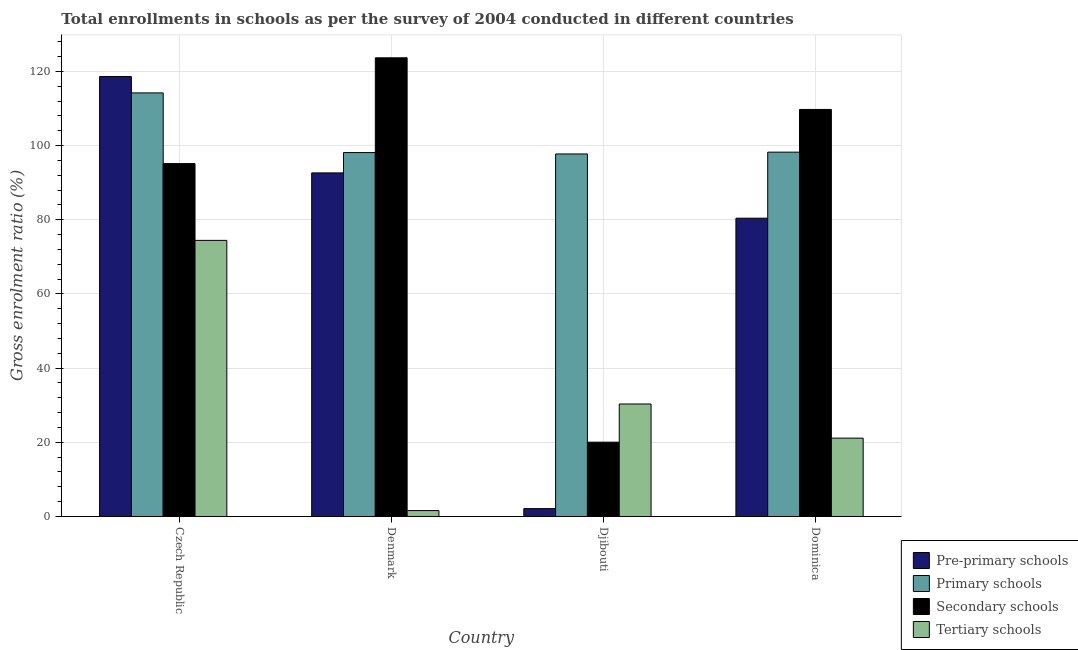How many groups of bars are there?
Your response must be concise. 4. Are the number of bars on each tick of the X-axis equal?
Keep it short and to the point. Yes. How many bars are there on the 1st tick from the left?
Give a very brief answer. 4. What is the label of the 3rd group of bars from the left?
Keep it short and to the point. Djibouti. What is the gross enrolment ratio in pre-primary schools in Dominica?
Your response must be concise. 80.43. Across all countries, what is the maximum gross enrolment ratio in tertiary schools?
Your answer should be compact. 74.44. Across all countries, what is the minimum gross enrolment ratio in primary schools?
Give a very brief answer. 97.75. In which country was the gross enrolment ratio in primary schools maximum?
Provide a short and direct response. Czech Republic. In which country was the gross enrolment ratio in pre-primary schools minimum?
Make the answer very short. Djibouti. What is the total gross enrolment ratio in primary schools in the graph?
Make the answer very short. 408.3. What is the difference between the gross enrolment ratio in tertiary schools in Denmark and that in Djibouti?
Provide a short and direct response. -28.74. What is the difference between the gross enrolment ratio in pre-primary schools in Denmark and the gross enrolment ratio in secondary schools in Czech Republic?
Keep it short and to the point. -2.51. What is the average gross enrolment ratio in pre-primary schools per country?
Your answer should be very brief. 73.45. What is the difference between the gross enrolment ratio in primary schools and gross enrolment ratio in tertiary schools in Dominica?
Provide a succinct answer. 77.1. What is the ratio of the gross enrolment ratio in pre-primary schools in Djibouti to that in Dominica?
Give a very brief answer. 0.03. Is the gross enrolment ratio in pre-primary schools in Czech Republic less than that in Denmark?
Provide a short and direct response. No. Is the difference between the gross enrolment ratio in secondary schools in Czech Republic and Dominica greater than the difference between the gross enrolment ratio in pre-primary schools in Czech Republic and Dominica?
Your answer should be very brief. No. What is the difference between the highest and the second highest gross enrolment ratio in pre-primary schools?
Give a very brief answer. 25.98. What is the difference between the highest and the lowest gross enrolment ratio in secondary schools?
Make the answer very short. 103.63. In how many countries, is the gross enrolment ratio in primary schools greater than the average gross enrolment ratio in primary schools taken over all countries?
Provide a succinct answer. 1. What does the 2nd bar from the left in Denmark represents?
Ensure brevity in your answer.  Primary schools. What does the 3rd bar from the right in Denmark represents?
Make the answer very short. Primary schools. Is it the case that in every country, the sum of the gross enrolment ratio in pre-primary schools and gross enrolment ratio in primary schools is greater than the gross enrolment ratio in secondary schools?
Give a very brief answer. Yes. How many countries are there in the graph?
Give a very brief answer. 4. What is the difference between two consecutive major ticks on the Y-axis?
Ensure brevity in your answer.  20. Are the values on the major ticks of Y-axis written in scientific E-notation?
Ensure brevity in your answer.  No. Does the graph contain grids?
Offer a very short reply. Yes. Where does the legend appear in the graph?
Your response must be concise. Bottom right. How are the legend labels stacked?
Your answer should be very brief. Vertical. What is the title of the graph?
Your answer should be compact. Total enrollments in schools as per the survey of 2004 conducted in different countries. What is the label or title of the Y-axis?
Your answer should be very brief. Gross enrolment ratio (%). What is the Gross enrolment ratio (%) in Pre-primary schools in Czech Republic?
Give a very brief answer. 118.62. What is the Gross enrolment ratio (%) of Primary schools in Czech Republic?
Offer a terse response. 114.2. What is the Gross enrolment ratio (%) of Secondary schools in Czech Republic?
Provide a short and direct response. 95.15. What is the Gross enrolment ratio (%) in Tertiary schools in Czech Republic?
Give a very brief answer. 74.44. What is the Gross enrolment ratio (%) in Pre-primary schools in Denmark?
Offer a very short reply. 92.64. What is the Gross enrolment ratio (%) in Primary schools in Denmark?
Give a very brief answer. 98.12. What is the Gross enrolment ratio (%) of Secondary schools in Denmark?
Give a very brief answer. 123.67. What is the Gross enrolment ratio (%) of Tertiary schools in Denmark?
Your answer should be very brief. 1.59. What is the Gross enrolment ratio (%) of Pre-primary schools in Djibouti?
Provide a succinct answer. 2.12. What is the Gross enrolment ratio (%) of Primary schools in Djibouti?
Provide a short and direct response. 97.75. What is the Gross enrolment ratio (%) of Secondary schools in Djibouti?
Offer a very short reply. 20.04. What is the Gross enrolment ratio (%) of Tertiary schools in Djibouti?
Make the answer very short. 30.33. What is the Gross enrolment ratio (%) of Pre-primary schools in Dominica?
Ensure brevity in your answer.  80.43. What is the Gross enrolment ratio (%) in Primary schools in Dominica?
Your response must be concise. 98.23. What is the Gross enrolment ratio (%) in Secondary schools in Dominica?
Give a very brief answer. 109.75. What is the Gross enrolment ratio (%) in Tertiary schools in Dominica?
Your answer should be compact. 21.13. Across all countries, what is the maximum Gross enrolment ratio (%) of Pre-primary schools?
Your response must be concise. 118.62. Across all countries, what is the maximum Gross enrolment ratio (%) of Primary schools?
Ensure brevity in your answer.  114.2. Across all countries, what is the maximum Gross enrolment ratio (%) in Secondary schools?
Your answer should be compact. 123.67. Across all countries, what is the maximum Gross enrolment ratio (%) of Tertiary schools?
Ensure brevity in your answer.  74.44. Across all countries, what is the minimum Gross enrolment ratio (%) in Pre-primary schools?
Ensure brevity in your answer.  2.12. Across all countries, what is the minimum Gross enrolment ratio (%) of Primary schools?
Your answer should be very brief. 97.75. Across all countries, what is the minimum Gross enrolment ratio (%) in Secondary schools?
Keep it short and to the point. 20.04. Across all countries, what is the minimum Gross enrolment ratio (%) of Tertiary schools?
Make the answer very short. 1.59. What is the total Gross enrolment ratio (%) in Pre-primary schools in the graph?
Ensure brevity in your answer.  293.8. What is the total Gross enrolment ratio (%) in Primary schools in the graph?
Provide a short and direct response. 408.3. What is the total Gross enrolment ratio (%) of Secondary schools in the graph?
Your answer should be very brief. 348.6. What is the total Gross enrolment ratio (%) of Tertiary schools in the graph?
Your answer should be compact. 127.49. What is the difference between the Gross enrolment ratio (%) of Pre-primary schools in Czech Republic and that in Denmark?
Give a very brief answer. 25.98. What is the difference between the Gross enrolment ratio (%) of Primary schools in Czech Republic and that in Denmark?
Make the answer very short. 16.09. What is the difference between the Gross enrolment ratio (%) in Secondary schools in Czech Republic and that in Denmark?
Offer a terse response. -28.52. What is the difference between the Gross enrolment ratio (%) in Tertiary schools in Czech Republic and that in Denmark?
Provide a short and direct response. 72.85. What is the difference between the Gross enrolment ratio (%) in Pre-primary schools in Czech Republic and that in Djibouti?
Keep it short and to the point. 116.49. What is the difference between the Gross enrolment ratio (%) of Primary schools in Czech Republic and that in Djibouti?
Offer a terse response. 16.46. What is the difference between the Gross enrolment ratio (%) of Secondary schools in Czech Republic and that in Djibouti?
Make the answer very short. 75.11. What is the difference between the Gross enrolment ratio (%) in Tertiary schools in Czech Republic and that in Djibouti?
Ensure brevity in your answer.  44.11. What is the difference between the Gross enrolment ratio (%) in Pre-primary schools in Czech Republic and that in Dominica?
Your response must be concise. 38.19. What is the difference between the Gross enrolment ratio (%) in Primary schools in Czech Republic and that in Dominica?
Keep it short and to the point. 15.97. What is the difference between the Gross enrolment ratio (%) in Secondary schools in Czech Republic and that in Dominica?
Offer a very short reply. -14.6. What is the difference between the Gross enrolment ratio (%) of Tertiary schools in Czech Republic and that in Dominica?
Your response must be concise. 53.32. What is the difference between the Gross enrolment ratio (%) of Pre-primary schools in Denmark and that in Djibouti?
Offer a terse response. 90.51. What is the difference between the Gross enrolment ratio (%) in Primary schools in Denmark and that in Djibouti?
Provide a short and direct response. 0.37. What is the difference between the Gross enrolment ratio (%) of Secondary schools in Denmark and that in Djibouti?
Offer a very short reply. 103.63. What is the difference between the Gross enrolment ratio (%) in Tertiary schools in Denmark and that in Djibouti?
Keep it short and to the point. -28.74. What is the difference between the Gross enrolment ratio (%) of Pre-primary schools in Denmark and that in Dominica?
Provide a short and direct response. 12.21. What is the difference between the Gross enrolment ratio (%) of Primary schools in Denmark and that in Dominica?
Your answer should be compact. -0.11. What is the difference between the Gross enrolment ratio (%) of Secondary schools in Denmark and that in Dominica?
Offer a very short reply. 13.92. What is the difference between the Gross enrolment ratio (%) in Tertiary schools in Denmark and that in Dominica?
Ensure brevity in your answer.  -19.54. What is the difference between the Gross enrolment ratio (%) of Pre-primary schools in Djibouti and that in Dominica?
Your response must be concise. -78.3. What is the difference between the Gross enrolment ratio (%) in Primary schools in Djibouti and that in Dominica?
Keep it short and to the point. -0.49. What is the difference between the Gross enrolment ratio (%) in Secondary schools in Djibouti and that in Dominica?
Your answer should be compact. -89.71. What is the difference between the Gross enrolment ratio (%) in Tertiary schools in Djibouti and that in Dominica?
Ensure brevity in your answer.  9.2. What is the difference between the Gross enrolment ratio (%) of Pre-primary schools in Czech Republic and the Gross enrolment ratio (%) of Primary schools in Denmark?
Your answer should be compact. 20.5. What is the difference between the Gross enrolment ratio (%) of Pre-primary schools in Czech Republic and the Gross enrolment ratio (%) of Secondary schools in Denmark?
Your answer should be compact. -5.05. What is the difference between the Gross enrolment ratio (%) in Pre-primary schools in Czech Republic and the Gross enrolment ratio (%) in Tertiary schools in Denmark?
Your answer should be very brief. 117.03. What is the difference between the Gross enrolment ratio (%) in Primary schools in Czech Republic and the Gross enrolment ratio (%) in Secondary schools in Denmark?
Offer a terse response. -9.46. What is the difference between the Gross enrolment ratio (%) of Primary schools in Czech Republic and the Gross enrolment ratio (%) of Tertiary schools in Denmark?
Your answer should be very brief. 112.62. What is the difference between the Gross enrolment ratio (%) in Secondary schools in Czech Republic and the Gross enrolment ratio (%) in Tertiary schools in Denmark?
Your response must be concise. 93.56. What is the difference between the Gross enrolment ratio (%) in Pre-primary schools in Czech Republic and the Gross enrolment ratio (%) in Primary schools in Djibouti?
Provide a succinct answer. 20.87. What is the difference between the Gross enrolment ratio (%) in Pre-primary schools in Czech Republic and the Gross enrolment ratio (%) in Secondary schools in Djibouti?
Offer a terse response. 98.58. What is the difference between the Gross enrolment ratio (%) of Pre-primary schools in Czech Republic and the Gross enrolment ratio (%) of Tertiary schools in Djibouti?
Your answer should be compact. 88.29. What is the difference between the Gross enrolment ratio (%) of Primary schools in Czech Republic and the Gross enrolment ratio (%) of Secondary schools in Djibouti?
Keep it short and to the point. 94.17. What is the difference between the Gross enrolment ratio (%) in Primary schools in Czech Republic and the Gross enrolment ratio (%) in Tertiary schools in Djibouti?
Offer a terse response. 83.88. What is the difference between the Gross enrolment ratio (%) of Secondary schools in Czech Republic and the Gross enrolment ratio (%) of Tertiary schools in Djibouti?
Provide a short and direct response. 64.82. What is the difference between the Gross enrolment ratio (%) in Pre-primary schools in Czech Republic and the Gross enrolment ratio (%) in Primary schools in Dominica?
Keep it short and to the point. 20.38. What is the difference between the Gross enrolment ratio (%) in Pre-primary schools in Czech Republic and the Gross enrolment ratio (%) in Secondary schools in Dominica?
Give a very brief answer. 8.87. What is the difference between the Gross enrolment ratio (%) in Pre-primary schools in Czech Republic and the Gross enrolment ratio (%) in Tertiary schools in Dominica?
Provide a short and direct response. 97.49. What is the difference between the Gross enrolment ratio (%) in Primary schools in Czech Republic and the Gross enrolment ratio (%) in Secondary schools in Dominica?
Offer a very short reply. 4.46. What is the difference between the Gross enrolment ratio (%) in Primary schools in Czech Republic and the Gross enrolment ratio (%) in Tertiary schools in Dominica?
Provide a succinct answer. 93.08. What is the difference between the Gross enrolment ratio (%) of Secondary schools in Czech Republic and the Gross enrolment ratio (%) of Tertiary schools in Dominica?
Provide a short and direct response. 74.02. What is the difference between the Gross enrolment ratio (%) in Pre-primary schools in Denmark and the Gross enrolment ratio (%) in Primary schools in Djibouti?
Offer a very short reply. -5.11. What is the difference between the Gross enrolment ratio (%) of Pre-primary schools in Denmark and the Gross enrolment ratio (%) of Secondary schools in Djibouti?
Your response must be concise. 72.6. What is the difference between the Gross enrolment ratio (%) in Pre-primary schools in Denmark and the Gross enrolment ratio (%) in Tertiary schools in Djibouti?
Make the answer very short. 62.31. What is the difference between the Gross enrolment ratio (%) in Primary schools in Denmark and the Gross enrolment ratio (%) in Secondary schools in Djibouti?
Provide a succinct answer. 78.08. What is the difference between the Gross enrolment ratio (%) in Primary schools in Denmark and the Gross enrolment ratio (%) in Tertiary schools in Djibouti?
Offer a terse response. 67.79. What is the difference between the Gross enrolment ratio (%) in Secondary schools in Denmark and the Gross enrolment ratio (%) in Tertiary schools in Djibouti?
Make the answer very short. 93.34. What is the difference between the Gross enrolment ratio (%) of Pre-primary schools in Denmark and the Gross enrolment ratio (%) of Primary schools in Dominica?
Offer a very short reply. -5.59. What is the difference between the Gross enrolment ratio (%) of Pre-primary schools in Denmark and the Gross enrolment ratio (%) of Secondary schools in Dominica?
Your answer should be compact. -17.11. What is the difference between the Gross enrolment ratio (%) of Pre-primary schools in Denmark and the Gross enrolment ratio (%) of Tertiary schools in Dominica?
Give a very brief answer. 71.51. What is the difference between the Gross enrolment ratio (%) in Primary schools in Denmark and the Gross enrolment ratio (%) in Secondary schools in Dominica?
Make the answer very short. -11.63. What is the difference between the Gross enrolment ratio (%) of Primary schools in Denmark and the Gross enrolment ratio (%) of Tertiary schools in Dominica?
Keep it short and to the point. 76.99. What is the difference between the Gross enrolment ratio (%) in Secondary schools in Denmark and the Gross enrolment ratio (%) in Tertiary schools in Dominica?
Provide a short and direct response. 102.54. What is the difference between the Gross enrolment ratio (%) in Pre-primary schools in Djibouti and the Gross enrolment ratio (%) in Primary schools in Dominica?
Your answer should be compact. -96.11. What is the difference between the Gross enrolment ratio (%) of Pre-primary schools in Djibouti and the Gross enrolment ratio (%) of Secondary schools in Dominica?
Your response must be concise. -107.62. What is the difference between the Gross enrolment ratio (%) in Pre-primary schools in Djibouti and the Gross enrolment ratio (%) in Tertiary schools in Dominica?
Provide a short and direct response. -19. What is the difference between the Gross enrolment ratio (%) of Primary schools in Djibouti and the Gross enrolment ratio (%) of Secondary schools in Dominica?
Provide a succinct answer. -12. What is the difference between the Gross enrolment ratio (%) of Primary schools in Djibouti and the Gross enrolment ratio (%) of Tertiary schools in Dominica?
Your response must be concise. 76.62. What is the difference between the Gross enrolment ratio (%) in Secondary schools in Djibouti and the Gross enrolment ratio (%) in Tertiary schools in Dominica?
Keep it short and to the point. -1.09. What is the average Gross enrolment ratio (%) of Pre-primary schools per country?
Give a very brief answer. 73.45. What is the average Gross enrolment ratio (%) in Primary schools per country?
Provide a succinct answer. 102.07. What is the average Gross enrolment ratio (%) in Secondary schools per country?
Ensure brevity in your answer.  87.15. What is the average Gross enrolment ratio (%) in Tertiary schools per country?
Offer a very short reply. 31.87. What is the difference between the Gross enrolment ratio (%) in Pre-primary schools and Gross enrolment ratio (%) in Primary schools in Czech Republic?
Your response must be concise. 4.41. What is the difference between the Gross enrolment ratio (%) of Pre-primary schools and Gross enrolment ratio (%) of Secondary schools in Czech Republic?
Offer a terse response. 23.47. What is the difference between the Gross enrolment ratio (%) in Pre-primary schools and Gross enrolment ratio (%) in Tertiary schools in Czech Republic?
Offer a very short reply. 44.17. What is the difference between the Gross enrolment ratio (%) of Primary schools and Gross enrolment ratio (%) of Secondary schools in Czech Republic?
Your response must be concise. 19.06. What is the difference between the Gross enrolment ratio (%) in Primary schools and Gross enrolment ratio (%) in Tertiary schools in Czech Republic?
Your answer should be compact. 39.76. What is the difference between the Gross enrolment ratio (%) of Secondary schools and Gross enrolment ratio (%) of Tertiary schools in Czech Republic?
Your answer should be compact. 20.7. What is the difference between the Gross enrolment ratio (%) of Pre-primary schools and Gross enrolment ratio (%) of Primary schools in Denmark?
Your answer should be very brief. -5.48. What is the difference between the Gross enrolment ratio (%) in Pre-primary schools and Gross enrolment ratio (%) in Secondary schools in Denmark?
Provide a short and direct response. -31.03. What is the difference between the Gross enrolment ratio (%) in Pre-primary schools and Gross enrolment ratio (%) in Tertiary schools in Denmark?
Ensure brevity in your answer.  91.05. What is the difference between the Gross enrolment ratio (%) in Primary schools and Gross enrolment ratio (%) in Secondary schools in Denmark?
Give a very brief answer. -25.55. What is the difference between the Gross enrolment ratio (%) of Primary schools and Gross enrolment ratio (%) of Tertiary schools in Denmark?
Offer a terse response. 96.53. What is the difference between the Gross enrolment ratio (%) in Secondary schools and Gross enrolment ratio (%) in Tertiary schools in Denmark?
Give a very brief answer. 122.08. What is the difference between the Gross enrolment ratio (%) in Pre-primary schools and Gross enrolment ratio (%) in Primary schools in Djibouti?
Make the answer very short. -95.62. What is the difference between the Gross enrolment ratio (%) of Pre-primary schools and Gross enrolment ratio (%) of Secondary schools in Djibouti?
Your response must be concise. -17.91. What is the difference between the Gross enrolment ratio (%) of Pre-primary schools and Gross enrolment ratio (%) of Tertiary schools in Djibouti?
Offer a terse response. -28.21. What is the difference between the Gross enrolment ratio (%) of Primary schools and Gross enrolment ratio (%) of Secondary schools in Djibouti?
Keep it short and to the point. 77.71. What is the difference between the Gross enrolment ratio (%) in Primary schools and Gross enrolment ratio (%) in Tertiary schools in Djibouti?
Offer a terse response. 67.42. What is the difference between the Gross enrolment ratio (%) of Secondary schools and Gross enrolment ratio (%) of Tertiary schools in Djibouti?
Your answer should be compact. -10.29. What is the difference between the Gross enrolment ratio (%) in Pre-primary schools and Gross enrolment ratio (%) in Primary schools in Dominica?
Your answer should be very brief. -17.8. What is the difference between the Gross enrolment ratio (%) of Pre-primary schools and Gross enrolment ratio (%) of Secondary schools in Dominica?
Your answer should be compact. -29.32. What is the difference between the Gross enrolment ratio (%) in Pre-primary schools and Gross enrolment ratio (%) in Tertiary schools in Dominica?
Provide a short and direct response. 59.3. What is the difference between the Gross enrolment ratio (%) of Primary schools and Gross enrolment ratio (%) of Secondary schools in Dominica?
Make the answer very short. -11.52. What is the difference between the Gross enrolment ratio (%) of Primary schools and Gross enrolment ratio (%) of Tertiary schools in Dominica?
Make the answer very short. 77.1. What is the difference between the Gross enrolment ratio (%) of Secondary schools and Gross enrolment ratio (%) of Tertiary schools in Dominica?
Your answer should be very brief. 88.62. What is the ratio of the Gross enrolment ratio (%) in Pre-primary schools in Czech Republic to that in Denmark?
Offer a very short reply. 1.28. What is the ratio of the Gross enrolment ratio (%) in Primary schools in Czech Republic to that in Denmark?
Your answer should be compact. 1.16. What is the ratio of the Gross enrolment ratio (%) of Secondary schools in Czech Republic to that in Denmark?
Make the answer very short. 0.77. What is the ratio of the Gross enrolment ratio (%) in Tertiary schools in Czech Republic to that in Denmark?
Your answer should be very brief. 46.86. What is the ratio of the Gross enrolment ratio (%) in Pre-primary schools in Czech Republic to that in Djibouti?
Offer a very short reply. 55.86. What is the ratio of the Gross enrolment ratio (%) in Primary schools in Czech Republic to that in Djibouti?
Your answer should be very brief. 1.17. What is the ratio of the Gross enrolment ratio (%) in Secondary schools in Czech Republic to that in Djibouti?
Ensure brevity in your answer.  4.75. What is the ratio of the Gross enrolment ratio (%) in Tertiary schools in Czech Republic to that in Djibouti?
Your answer should be very brief. 2.45. What is the ratio of the Gross enrolment ratio (%) in Pre-primary schools in Czech Republic to that in Dominica?
Provide a succinct answer. 1.47. What is the ratio of the Gross enrolment ratio (%) of Primary schools in Czech Republic to that in Dominica?
Give a very brief answer. 1.16. What is the ratio of the Gross enrolment ratio (%) of Secondary schools in Czech Republic to that in Dominica?
Your response must be concise. 0.87. What is the ratio of the Gross enrolment ratio (%) of Tertiary schools in Czech Republic to that in Dominica?
Your answer should be compact. 3.52. What is the ratio of the Gross enrolment ratio (%) of Pre-primary schools in Denmark to that in Djibouti?
Give a very brief answer. 43.63. What is the ratio of the Gross enrolment ratio (%) of Secondary schools in Denmark to that in Djibouti?
Your response must be concise. 6.17. What is the ratio of the Gross enrolment ratio (%) in Tertiary schools in Denmark to that in Djibouti?
Your answer should be compact. 0.05. What is the ratio of the Gross enrolment ratio (%) of Pre-primary schools in Denmark to that in Dominica?
Your answer should be compact. 1.15. What is the ratio of the Gross enrolment ratio (%) of Secondary schools in Denmark to that in Dominica?
Provide a succinct answer. 1.13. What is the ratio of the Gross enrolment ratio (%) of Tertiary schools in Denmark to that in Dominica?
Ensure brevity in your answer.  0.08. What is the ratio of the Gross enrolment ratio (%) in Pre-primary schools in Djibouti to that in Dominica?
Your answer should be very brief. 0.03. What is the ratio of the Gross enrolment ratio (%) of Primary schools in Djibouti to that in Dominica?
Keep it short and to the point. 1. What is the ratio of the Gross enrolment ratio (%) of Secondary schools in Djibouti to that in Dominica?
Your answer should be very brief. 0.18. What is the ratio of the Gross enrolment ratio (%) of Tertiary schools in Djibouti to that in Dominica?
Your answer should be compact. 1.44. What is the difference between the highest and the second highest Gross enrolment ratio (%) in Pre-primary schools?
Your response must be concise. 25.98. What is the difference between the highest and the second highest Gross enrolment ratio (%) of Primary schools?
Offer a terse response. 15.97. What is the difference between the highest and the second highest Gross enrolment ratio (%) of Secondary schools?
Provide a succinct answer. 13.92. What is the difference between the highest and the second highest Gross enrolment ratio (%) of Tertiary schools?
Give a very brief answer. 44.11. What is the difference between the highest and the lowest Gross enrolment ratio (%) of Pre-primary schools?
Keep it short and to the point. 116.49. What is the difference between the highest and the lowest Gross enrolment ratio (%) in Primary schools?
Offer a very short reply. 16.46. What is the difference between the highest and the lowest Gross enrolment ratio (%) in Secondary schools?
Offer a very short reply. 103.63. What is the difference between the highest and the lowest Gross enrolment ratio (%) in Tertiary schools?
Your answer should be compact. 72.85. 